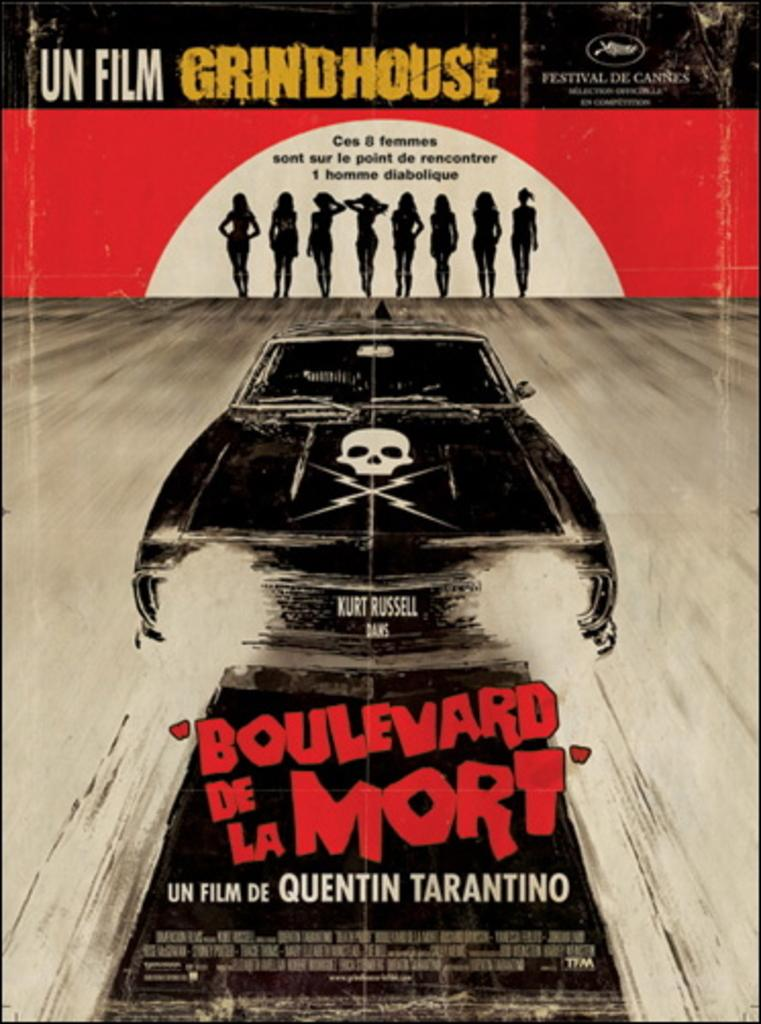<image>
Present a compact description of the photo's key features. Boulevard de la Mort is a film made by Quentin Tarantino. 